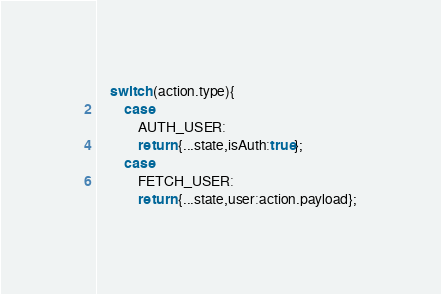<code> <loc_0><loc_0><loc_500><loc_500><_JavaScript_>    switch (action.type){
        case
            AUTH_USER:
            return {...state,isAuth:true};
        case
            FETCH_USER:
            return {...state,user:action.payload};</code> 